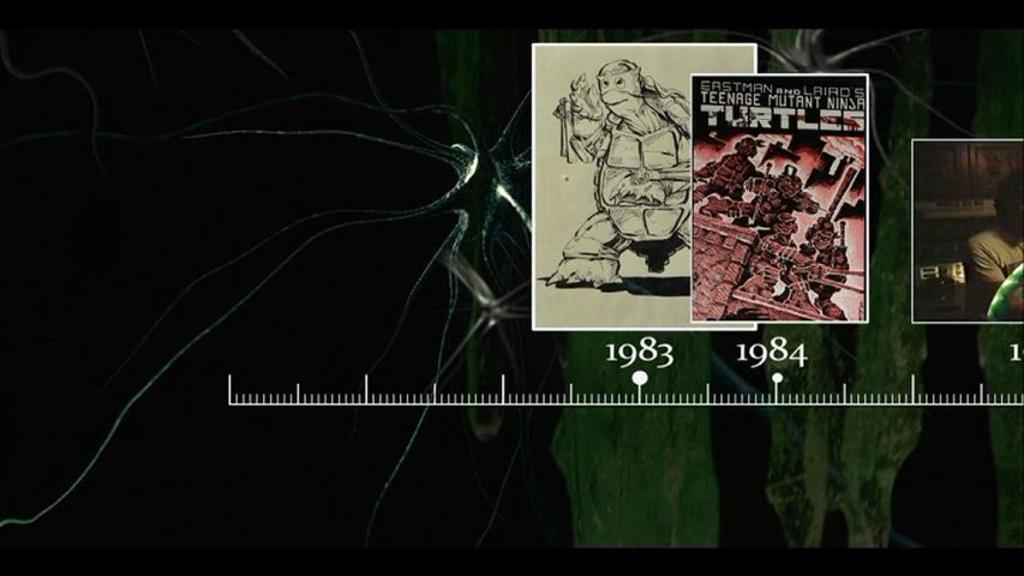What is the nature of the image? The image is edited. What can be seen in the middle of the image? There is a scale in the middle of the image. How is the image shaped? The image is in the shape of a turtle. How many children are playing with the tiger in the image? There are no children or tiger present in the image. What is the chance of winning the lottery in the image? There is no reference to a lottery or any chance of winning in the image. 